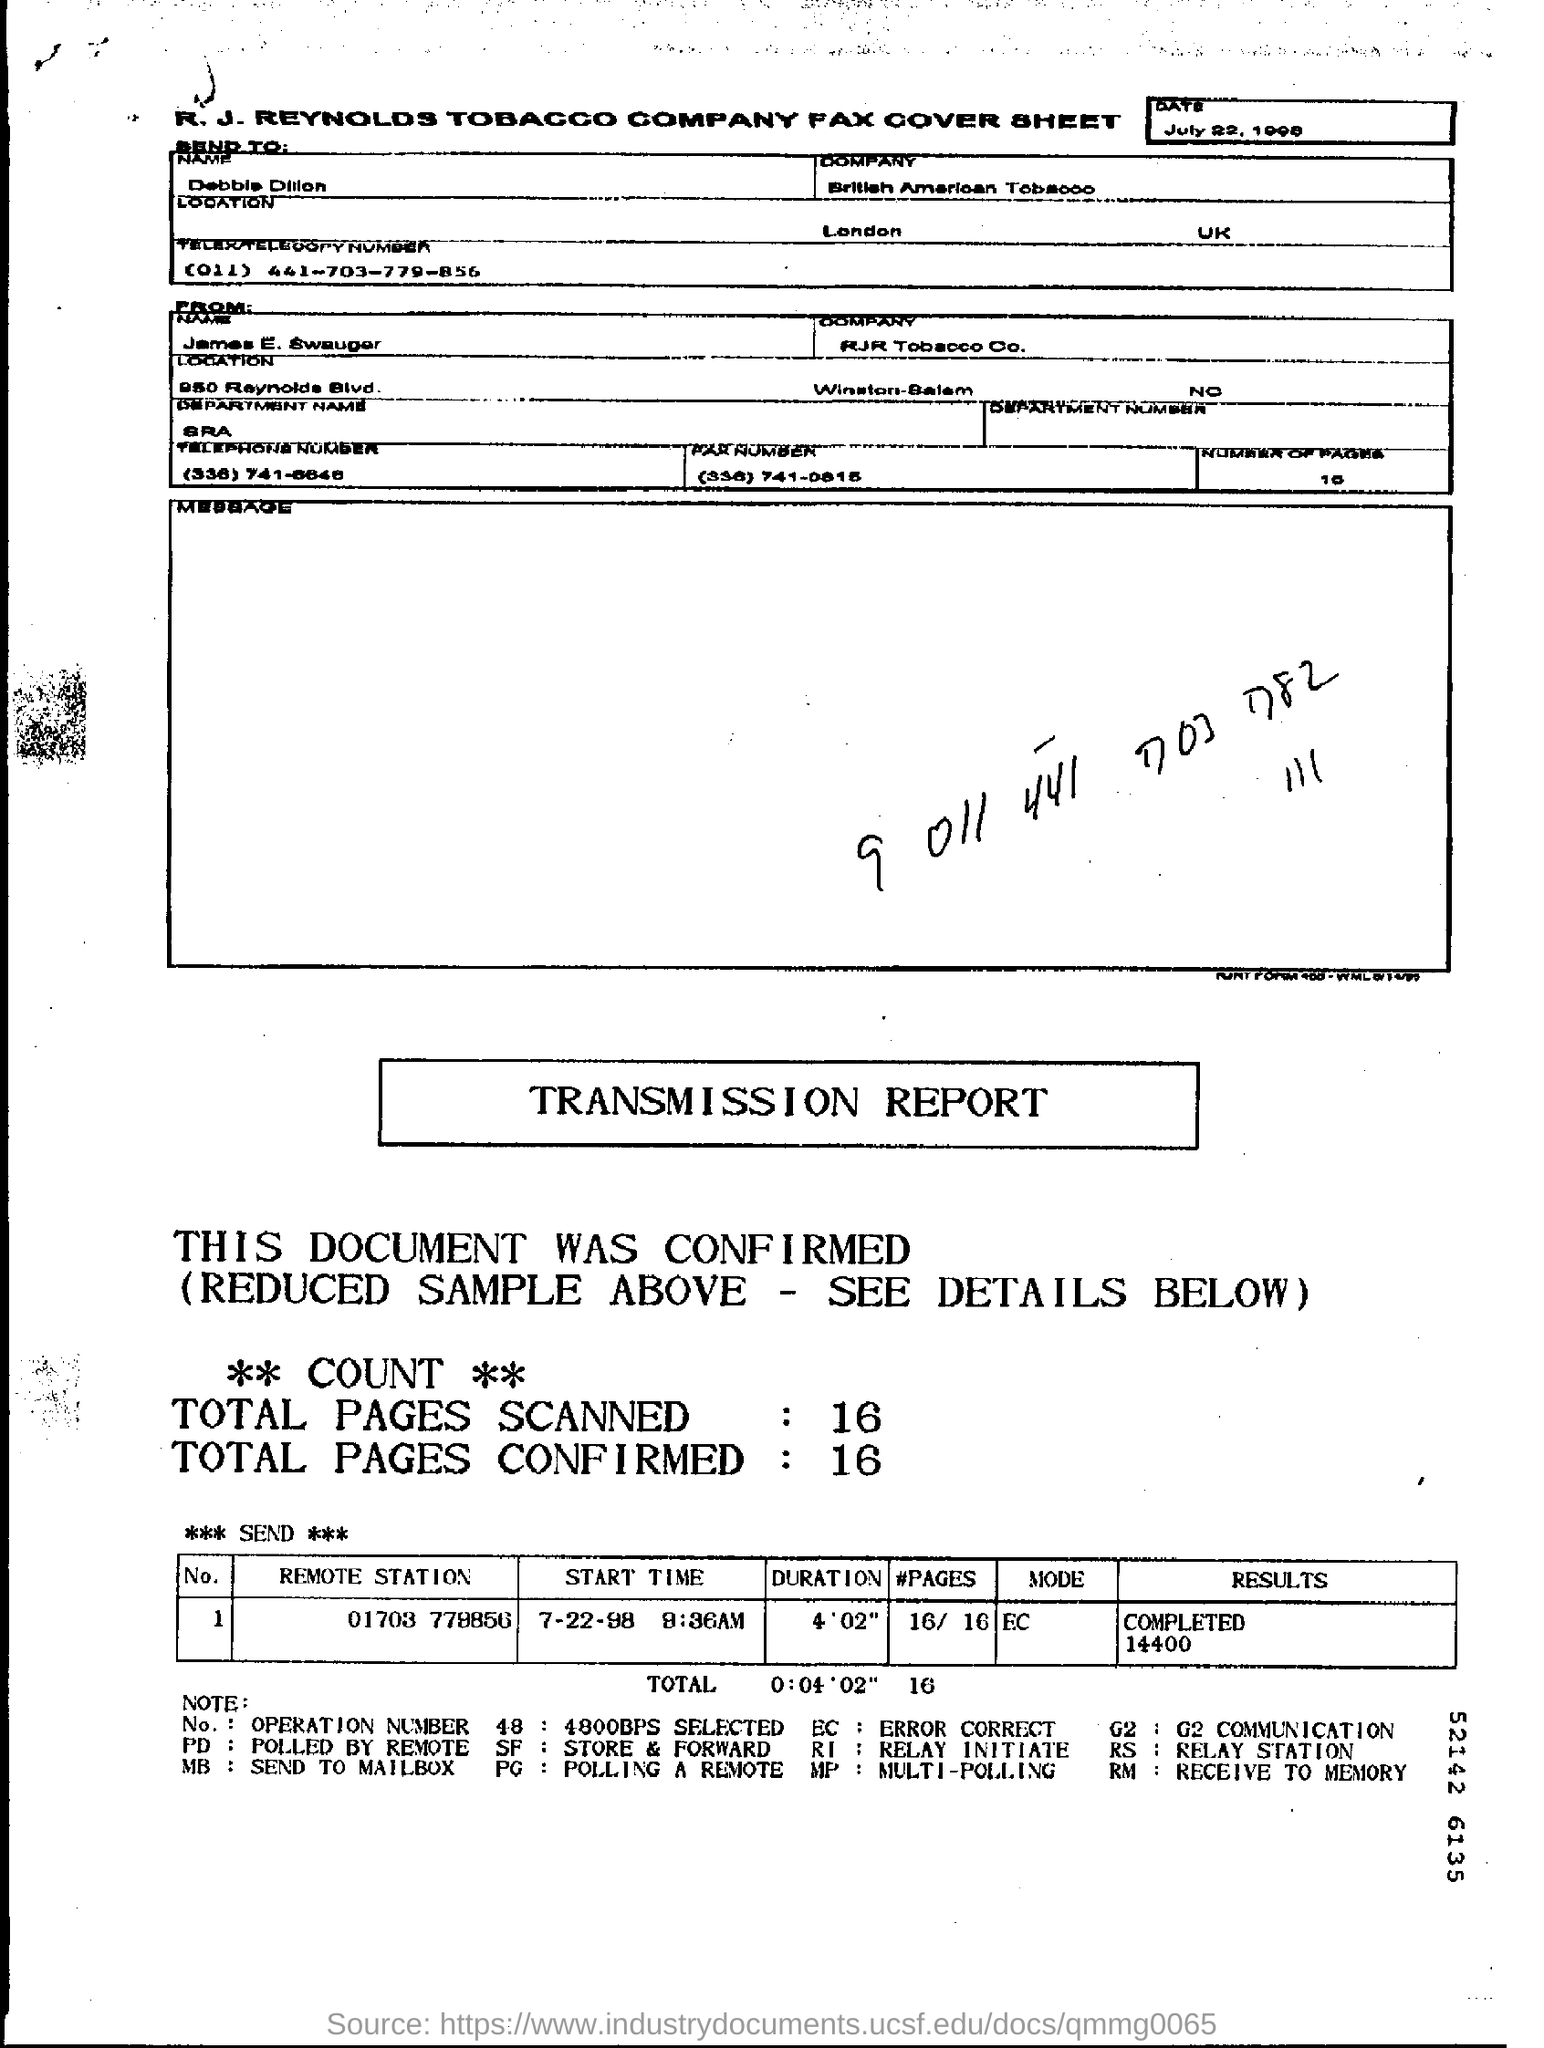Mention a couple of crucial points in this snapshot. The remote station number is 01703 778856. The sender of the message is James E. Swauger. As of the current date, the number of pages in the document is 10. The sender company is RJR Tobacco Company. 